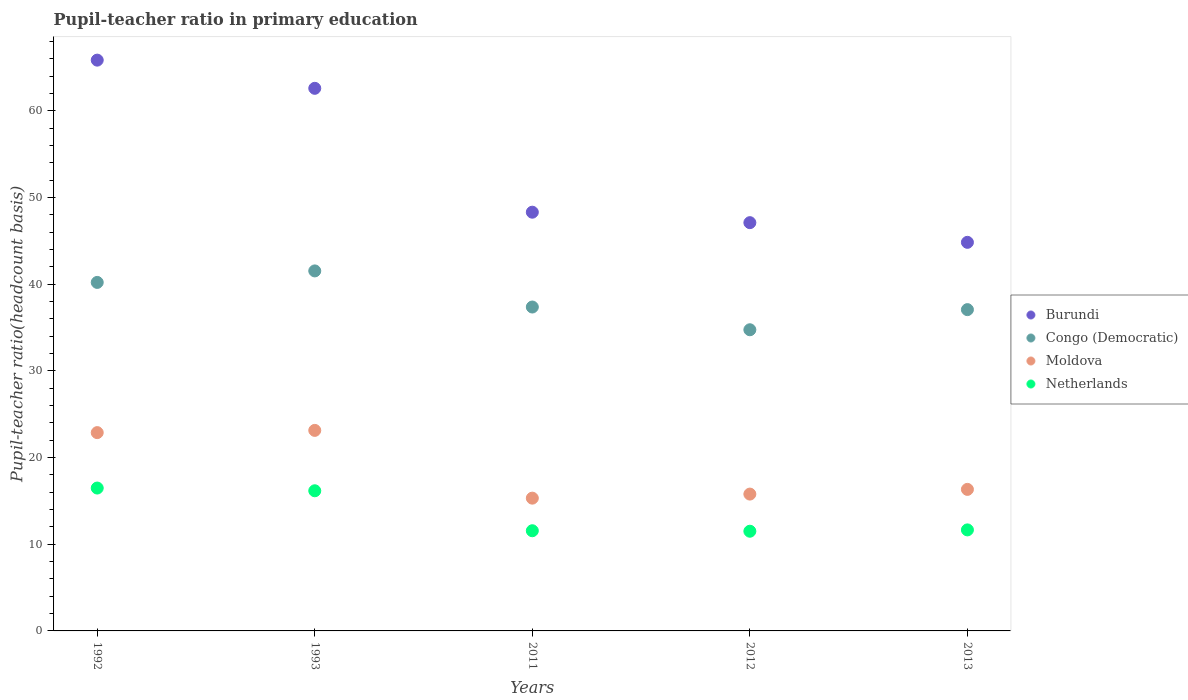How many different coloured dotlines are there?
Ensure brevity in your answer.  4. Is the number of dotlines equal to the number of legend labels?
Provide a short and direct response. Yes. What is the pupil-teacher ratio in primary education in Moldova in 2012?
Make the answer very short. 15.79. Across all years, what is the maximum pupil-teacher ratio in primary education in Netherlands?
Give a very brief answer. 16.48. Across all years, what is the minimum pupil-teacher ratio in primary education in Moldova?
Make the answer very short. 15.32. In which year was the pupil-teacher ratio in primary education in Burundi minimum?
Offer a terse response. 2013. What is the total pupil-teacher ratio in primary education in Burundi in the graph?
Your answer should be compact. 268.71. What is the difference between the pupil-teacher ratio in primary education in Congo (Democratic) in 1992 and that in 2013?
Offer a terse response. 3.14. What is the difference between the pupil-teacher ratio in primary education in Burundi in 1993 and the pupil-teacher ratio in primary education in Netherlands in 2012?
Your response must be concise. 51.1. What is the average pupil-teacher ratio in primary education in Netherlands per year?
Make the answer very short. 13.47. In the year 2011, what is the difference between the pupil-teacher ratio in primary education in Netherlands and pupil-teacher ratio in primary education in Congo (Democratic)?
Provide a short and direct response. -25.81. In how many years, is the pupil-teacher ratio in primary education in Burundi greater than 54?
Provide a short and direct response. 2. What is the ratio of the pupil-teacher ratio in primary education in Congo (Democratic) in 1992 to that in 1993?
Your answer should be very brief. 0.97. Is the pupil-teacher ratio in primary education in Netherlands in 1993 less than that in 2013?
Provide a short and direct response. No. What is the difference between the highest and the second highest pupil-teacher ratio in primary education in Moldova?
Your response must be concise. 0.26. What is the difference between the highest and the lowest pupil-teacher ratio in primary education in Burundi?
Give a very brief answer. 21.02. In how many years, is the pupil-teacher ratio in primary education in Burundi greater than the average pupil-teacher ratio in primary education in Burundi taken over all years?
Your answer should be very brief. 2. Is the sum of the pupil-teacher ratio in primary education in Moldova in 1993 and 2011 greater than the maximum pupil-teacher ratio in primary education in Congo (Democratic) across all years?
Provide a succinct answer. No. Is it the case that in every year, the sum of the pupil-teacher ratio in primary education in Burundi and pupil-teacher ratio in primary education in Moldova  is greater than the pupil-teacher ratio in primary education in Netherlands?
Provide a succinct answer. Yes. Does the pupil-teacher ratio in primary education in Burundi monotonically increase over the years?
Offer a terse response. No. Is the pupil-teacher ratio in primary education in Congo (Democratic) strictly greater than the pupil-teacher ratio in primary education in Netherlands over the years?
Give a very brief answer. Yes. How many dotlines are there?
Ensure brevity in your answer.  4. Where does the legend appear in the graph?
Make the answer very short. Center right. How are the legend labels stacked?
Provide a short and direct response. Vertical. What is the title of the graph?
Your answer should be compact. Pupil-teacher ratio in primary education. Does "Egypt, Arab Rep." appear as one of the legend labels in the graph?
Give a very brief answer. No. What is the label or title of the Y-axis?
Give a very brief answer. Pupil-teacher ratio(headcount basis). What is the Pupil-teacher ratio(headcount basis) in Burundi in 1992?
Offer a very short reply. 65.86. What is the Pupil-teacher ratio(headcount basis) of Congo (Democratic) in 1992?
Keep it short and to the point. 40.21. What is the Pupil-teacher ratio(headcount basis) of Moldova in 1992?
Your response must be concise. 22.88. What is the Pupil-teacher ratio(headcount basis) in Netherlands in 1992?
Offer a very short reply. 16.48. What is the Pupil-teacher ratio(headcount basis) in Burundi in 1993?
Your answer should be compact. 62.6. What is the Pupil-teacher ratio(headcount basis) in Congo (Democratic) in 1993?
Give a very brief answer. 41.54. What is the Pupil-teacher ratio(headcount basis) in Moldova in 1993?
Give a very brief answer. 23.14. What is the Pupil-teacher ratio(headcount basis) of Netherlands in 1993?
Your answer should be compact. 16.17. What is the Pupil-teacher ratio(headcount basis) of Burundi in 2011?
Your answer should be very brief. 48.31. What is the Pupil-teacher ratio(headcount basis) in Congo (Democratic) in 2011?
Offer a terse response. 37.37. What is the Pupil-teacher ratio(headcount basis) of Moldova in 2011?
Offer a terse response. 15.32. What is the Pupil-teacher ratio(headcount basis) of Netherlands in 2011?
Your answer should be very brief. 11.56. What is the Pupil-teacher ratio(headcount basis) in Burundi in 2012?
Provide a short and direct response. 47.1. What is the Pupil-teacher ratio(headcount basis) of Congo (Democratic) in 2012?
Offer a very short reply. 34.75. What is the Pupil-teacher ratio(headcount basis) in Moldova in 2012?
Provide a succinct answer. 15.79. What is the Pupil-teacher ratio(headcount basis) of Netherlands in 2012?
Keep it short and to the point. 11.5. What is the Pupil-teacher ratio(headcount basis) in Burundi in 2013?
Your answer should be very brief. 44.83. What is the Pupil-teacher ratio(headcount basis) in Congo (Democratic) in 2013?
Give a very brief answer. 37.07. What is the Pupil-teacher ratio(headcount basis) in Moldova in 2013?
Make the answer very short. 16.33. What is the Pupil-teacher ratio(headcount basis) in Netherlands in 2013?
Offer a terse response. 11.66. Across all years, what is the maximum Pupil-teacher ratio(headcount basis) in Burundi?
Offer a terse response. 65.86. Across all years, what is the maximum Pupil-teacher ratio(headcount basis) in Congo (Democratic)?
Your answer should be very brief. 41.54. Across all years, what is the maximum Pupil-teacher ratio(headcount basis) of Moldova?
Ensure brevity in your answer.  23.14. Across all years, what is the maximum Pupil-teacher ratio(headcount basis) of Netherlands?
Provide a succinct answer. 16.48. Across all years, what is the minimum Pupil-teacher ratio(headcount basis) of Burundi?
Make the answer very short. 44.83. Across all years, what is the minimum Pupil-teacher ratio(headcount basis) of Congo (Democratic)?
Your answer should be very brief. 34.75. Across all years, what is the minimum Pupil-teacher ratio(headcount basis) in Moldova?
Offer a very short reply. 15.32. Across all years, what is the minimum Pupil-teacher ratio(headcount basis) of Netherlands?
Provide a succinct answer. 11.5. What is the total Pupil-teacher ratio(headcount basis) of Burundi in the graph?
Give a very brief answer. 268.71. What is the total Pupil-teacher ratio(headcount basis) in Congo (Democratic) in the graph?
Provide a short and direct response. 190.93. What is the total Pupil-teacher ratio(headcount basis) in Moldova in the graph?
Provide a succinct answer. 93.45. What is the total Pupil-teacher ratio(headcount basis) of Netherlands in the graph?
Your answer should be compact. 67.37. What is the difference between the Pupil-teacher ratio(headcount basis) of Burundi in 1992 and that in 1993?
Provide a short and direct response. 3.25. What is the difference between the Pupil-teacher ratio(headcount basis) in Congo (Democratic) in 1992 and that in 1993?
Ensure brevity in your answer.  -1.33. What is the difference between the Pupil-teacher ratio(headcount basis) in Moldova in 1992 and that in 1993?
Your answer should be compact. -0.26. What is the difference between the Pupil-teacher ratio(headcount basis) in Netherlands in 1992 and that in 1993?
Your answer should be compact. 0.31. What is the difference between the Pupil-teacher ratio(headcount basis) of Burundi in 1992 and that in 2011?
Your answer should be very brief. 17.55. What is the difference between the Pupil-teacher ratio(headcount basis) in Congo (Democratic) in 1992 and that in 2011?
Make the answer very short. 2.84. What is the difference between the Pupil-teacher ratio(headcount basis) in Moldova in 1992 and that in 2011?
Ensure brevity in your answer.  7.56. What is the difference between the Pupil-teacher ratio(headcount basis) in Netherlands in 1992 and that in 2011?
Your answer should be compact. 4.93. What is the difference between the Pupil-teacher ratio(headcount basis) of Burundi in 1992 and that in 2012?
Your response must be concise. 18.75. What is the difference between the Pupil-teacher ratio(headcount basis) of Congo (Democratic) in 1992 and that in 2012?
Your answer should be very brief. 5.46. What is the difference between the Pupil-teacher ratio(headcount basis) in Moldova in 1992 and that in 2012?
Your answer should be compact. 7.09. What is the difference between the Pupil-teacher ratio(headcount basis) in Netherlands in 1992 and that in 2012?
Give a very brief answer. 4.98. What is the difference between the Pupil-teacher ratio(headcount basis) in Burundi in 1992 and that in 2013?
Make the answer very short. 21.02. What is the difference between the Pupil-teacher ratio(headcount basis) in Congo (Democratic) in 1992 and that in 2013?
Ensure brevity in your answer.  3.14. What is the difference between the Pupil-teacher ratio(headcount basis) in Moldova in 1992 and that in 2013?
Offer a terse response. 6.55. What is the difference between the Pupil-teacher ratio(headcount basis) of Netherlands in 1992 and that in 2013?
Your answer should be very brief. 4.83. What is the difference between the Pupil-teacher ratio(headcount basis) in Burundi in 1993 and that in 2011?
Your response must be concise. 14.29. What is the difference between the Pupil-teacher ratio(headcount basis) of Congo (Democratic) in 1993 and that in 2011?
Give a very brief answer. 4.17. What is the difference between the Pupil-teacher ratio(headcount basis) in Moldova in 1993 and that in 2011?
Offer a very short reply. 7.82. What is the difference between the Pupil-teacher ratio(headcount basis) in Netherlands in 1993 and that in 2011?
Provide a succinct answer. 4.61. What is the difference between the Pupil-teacher ratio(headcount basis) of Burundi in 1993 and that in 2012?
Give a very brief answer. 15.5. What is the difference between the Pupil-teacher ratio(headcount basis) in Congo (Democratic) in 1993 and that in 2012?
Keep it short and to the point. 6.79. What is the difference between the Pupil-teacher ratio(headcount basis) of Moldova in 1993 and that in 2012?
Make the answer very short. 7.35. What is the difference between the Pupil-teacher ratio(headcount basis) of Netherlands in 1993 and that in 2012?
Your response must be concise. 4.67. What is the difference between the Pupil-teacher ratio(headcount basis) of Burundi in 1993 and that in 2013?
Your response must be concise. 17.77. What is the difference between the Pupil-teacher ratio(headcount basis) of Congo (Democratic) in 1993 and that in 2013?
Keep it short and to the point. 4.47. What is the difference between the Pupil-teacher ratio(headcount basis) of Moldova in 1993 and that in 2013?
Your response must be concise. 6.81. What is the difference between the Pupil-teacher ratio(headcount basis) in Netherlands in 1993 and that in 2013?
Provide a succinct answer. 4.51. What is the difference between the Pupil-teacher ratio(headcount basis) of Burundi in 2011 and that in 2012?
Give a very brief answer. 1.21. What is the difference between the Pupil-teacher ratio(headcount basis) of Congo (Democratic) in 2011 and that in 2012?
Your answer should be compact. 2.62. What is the difference between the Pupil-teacher ratio(headcount basis) of Moldova in 2011 and that in 2012?
Your answer should be compact. -0.47. What is the difference between the Pupil-teacher ratio(headcount basis) in Netherlands in 2011 and that in 2012?
Provide a short and direct response. 0.06. What is the difference between the Pupil-teacher ratio(headcount basis) of Burundi in 2011 and that in 2013?
Ensure brevity in your answer.  3.48. What is the difference between the Pupil-teacher ratio(headcount basis) in Congo (Democratic) in 2011 and that in 2013?
Provide a succinct answer. 0.3. What is the difference between the Pupil-teacher ratio(headcount basis) of Moldova in 2011 and that in 2013?
Your response must be concise. -1.01. What is the difference between the Pupil-teacher ratio(headcount basis) in Netherlands in 2011 and that in 2013?
Provide a short and direct response. -0.1. What is the difference between the Pupil-teacher ratio(headcount basis) of Burundi in 2012 and that in 2013?
Keep it short and to the point. 2.27. What is the difference between the Pupil-teacher ratio(headcount basis) of Congo (Democratic) in 2012 and that in 2013?
Provide a succinct answer. -2.32. What is the difference between the Pupil-teacher ratio(headcount basis) in Moldova in 2012 and that in 2013?
Keep it short and to the point. -0.54. What is the difference between the Pupil-teacher ratio(headcount basis) in Netherlands in 2012 and that in 2013?
Provide a succinct answer. -0.15. What is the difference between the Pupil-teacher ratio(headcount basis) in Burundi in 1992 and the Pupil-teacher ratio(headcount basis) in Congo (Democratic) in 1993?
Make the answer very short. 24.32. What is the difference between the Pupil-teacher ratio(headcount basis) of Burundi in 1992 and the Pupil-teacher ratio(headcount basis) of Moldova in 1993?
Keep it short and to the point. 42.72. What is the difference between the Pupil-teacher ratio(headcount basis) of Burundi in 1992 and the Pupil-teacher ratio(headcount basis) of Netherlands in 1993?
Provide a succinct answer. 49.69. What is the difference between the Pupil-teacher ratio(headcount basis) of Congo (Democratic) in 1992 and the Pupil-teacher ratio(headcount basis) of Moldova in 1993?
Make the answer very short. 17.07. What is the difference between the Pupil-teacher ratio(headcount basis) of Congo (Democratic) in 1992 and the Pupil-teacher ratio(headcount basis) of Netherlands in 1993?
Make the answer very short. 24.04. What is the difference between the Pupil-teacher ratio(headcount basis) in Moldova in 1992 and the Pupil-teacher ratio(headcount basis) in Netherlands in 1993?
Provide a short and direct response. 6.71. What is the difference between the Pupil-teacher ratio(headcount basis) of Burundi in 1992 and the Pupil-teacher ratio(headcount basis) of Congo (Democratic) in 2011?
Offer a terse response. 28.49. What is the difference between the Pupil-teacher ratio(headcount basis) in Burundi in 1992 and the Pupil-teacher ratio(headcount basis) in Moldova in 2011?
Make the answer very short. 50.54. What is the difference between the Pupil-teacher ratio(headcount basis) in Burundi in 1992 and the Pupil-teacher ratio(headcount basis) in Netherlands in 2011?
Provide a succinct answer. 54.3. What is the difference between the Pupil-teacher ratio(headcount basis) of Congo (Democratic) in 1992 and the Pupil-teacher ratio(headcount basis) of Moldova in 2011?
Ensure brevity in your answer.  24.89. What is the difference between the Pupil-teacher ratio(headcount basis) of Congo (Democratic) in 1992 and the Pupil-teacher ratio(headcount basis) of Netherlands in 2011?
Provide a short and direct response. 28.65. What is the difference between the Pupil-teacher ratio(headcount basis) in Moldova in 1992 and the Pupil-teacher ratio(headcount basis) in Netherlands in 2011?
Give a very brief answer. 11.32. What is the difference between the Pupil-teacher ratio(headcount basis) in Burundi in 1992 and the Pupil-teacher ratio(headcount basis) in Congo (Democratic) in 2012?
Your answer should be very brief. 31.11. What is the difference between the Pupil-teacher ratio(headcount basis) in Burundi in 1992 and the Pupil-teacher ratio(headcount basis) in Moldova in 2012?
Your answer should be very brief. 50.07. What is the difference between the Pupil-teacher ratio(headcount basis) of Burundi in 1992 and the Pupil-teacher ratio(headcount basis) of Netherlands in 2012?
Your response must be concise. 54.35. What is the difference between the Pupil-teacher ratio(headcount basis) in Congo (Democratic) in 1992 and the Pupil-teacher ratio(headcount basis) in Moldova in 2012?
Provide a short and direct response. 24.42. What is the difference between the Pupil-teacher ratio(headcount basis) in Congo (Democratic) in 1992 and the Pupil-teacher ratio(headcount basis) in Netherlands in 2012?
Your answer should be compact. 28.71. What is the difference between the Pupil-teacher ratio(headcount basis) of Moldova in 1992 and the Pupil-teacher ratio(headcount basis) of Netherlands in 2012?
Make the answer very short. 11.38. What is the difference between the Pupil-teacher ratio(headcount basis) of Burundi in 1992 and the Pupil-teacher ratio(headcount basis) of Congo (Democratic) in 2013?
Offer a terse response. 28.79. What is the difference between the Pupil-teacher ratio(headcount basis) in Burundi in 1992 and the Pupil-teacher ratio(headcount basis) in Moldova in 2013?
Provide a succinct answer. 49.53. What is the difference between the Pupil-teacher ratio(headcount basis) in Burundi in 1992 and the Pupil-teacher ratio(headcount basis) in Netherlands in 2013?
Make the answer very short. 54.2. What is the difference between the Pupil-teacher ratio(headcount basis) in Congo (Democratic) in 1992 and the Pupil-teacher ratio(headcount basis) in Moldova in 2013?
Your response must be concise. 23.88. What is the difference between the Pupil-teacher ratio(headcount basis) in Congo (Democratic) in 1992 and the Pupil-teacher ratio(headcount basis) in Netherlands in 2013?
Make the answer very short. 28.55. What is the difference between the Pupil-teacher ratio(headcount basis) in Moldova in 1992 and the Pupil-teacher ratio(headcount basis) in Netherlands in 2013?
Your answer should be very brief. 11.22. What is the difference between the Pupil-teacher ratio(headcount basis) in Burundi in 1993 and the Pupil-teacher ratio(headcount basis) in Congo (Democratic) in 2011?
Offer a terse response. 25.23. What is the difference between the Pupil-teacher ratio(headcount basis) in Burundi in 1993 and the Pupil-teacher ratio(headcount basis) in Moldova in 2011?
Your response must be concise. 47.29. What is the difference between the Pupil-teacher ratio(headcount basis) in Burundi in 1993 and the Pupil-teacher ratio(headcount basis) in Netherlands in 2011?
Offer a very short reply. 51.05. What is the difference between the Pupil-teacher ratio(headcount basis) in Congo (Democratic) in 1993 and the Pupil-teacher ratio(headcount basis) in Moldova in 2011?
Provide a short and direct response. 26.22. What is the difference between the Pupil-teacher ratio(headcount basis) of Congo (Democratic) in 1993 and the Pupil-teacher ratio(headcount basis) of Netherlands in 2011?
Your response must be concise. 29.98. What is the difference between the Pupil-teacher ratio(headcount basis) in Moldova in 1993 and the Pupil-teacher ratio(headcount basis) in Netherlands in 2011?
Make the answer very short. 11.58. What is the difference between the Pupil-teacher ratio(headcount basis) of Burundi in 1993 and the Pupil-teacher ratio(headcount basis) of Congo (Democratic) in 2012?
Provide a succinct answer. 27.86. What is the difference between the Pupil-teacher ratio(headcount basis) in Burundi in 1993 and the Pupil-teacher ratio(headcount basis) in Moldova in 2012?
Offer a very short reply. 46.82. What is the difference between the Pupil-teacher ratio(headcount basis) in Burundi in 1993 and the Pupil-teacher ratio(headcount basis) in Netherlands in 2012?
Your response must be concise. 51.1. What is the difference between the Pupil-teacher ratio(headcount basis) of Congo (Democratic) in 1993 and the Pupil-teacher ratio(headcount basis) of Moldova in 2012?
Give a very brief answer. 25.75. What is the difference between the Pupil-teacher ratio(headcount basis) in Congo (Democratic) in 1993 and the Pupil-teacher ratio(headcount basis) in Netherlands in 2012?
Make the answer very short. 30.03. What is the difference between the Pupil-teacher ratio(headcount basis) in Moldova in 1993 and the Pupil-teacher ratio(headcount basis) in Netherlands in 2012?
Provide a succinct answer. 11.63. What is the difference between the Pupil-teacher ratio(headcount basis) in Burundi in 1993 and the Pupil-teacher ratio(headcount basis) in Congo (Democratic) in 2013?
Your answer should be compact. 25.54. What is the difference between the Pupil-teacher ratio(headcount basis) in Burundi in 1993 and the Pupil-teacher ratio(headcount basis) in Moldova in 2013?
Your response must be concise. 46.27. What is the difference between the Pupil-teacher ratio(headcount basis) of Burundi in 1993 and the Pupil-teacher ratio(headcount basis) of Netherlands in 2013?
Make the answer very short. 50.95. What is the difference between the Pupil-teacher ratio(headcount basis) in Congo (Democratic) in 1993 and the Pupil-teacher ratio(headcount basis) in Moldova in 2013?
Offer a terse response. 25.21. What is the difference between the Pupil-teacher ratio(headcount basis) of Congo (Democratic) in 1993 and the Pupil-teacher ratio(headcount basis) of Netherlands in 2013?
Make the answer very short. 29.88. What is the difference between the Pupil-teacher ratio(headcount basis) in Moldova in 1993 and the Pupil-teacher ratio(headcount basis) in Netherlands in 2013?
Provide a succinct answer. 11.48. What is the difference between the Pupil-teacher ratio(headcount basis) in Burundi in 2011 and the Pupil-teacher ratio(headcount basis) in Congo (Democratic) in 2012?
Your answer should be compact. 13.56. What is the difference between the Pupil-teacher ratio(headcount basis) of Burundi in 2011 and the Pupil-teacher ratio(headcount basis) of Moldova in 2012?
Your response must be concise. 32.52. What is the difference between the Pupil-teacher ratio(headcount basis) of Burundi in 2011 and the Pupil-teacher ratio(headcount basis) of Netherlands in 2012?
Your answer should be compact. 36.81. What is the difference between the Pupil-teacher ratio(headcount basis) in Congo (Democratic) in 2011 and the Pupil-teacher ratio(headcount basis) in Moldova in 2012?
Ensure brevity in your answer.  21.58. What is the difference between the Pupil-teacher ratio(headcount basis) of Congo (Democratic) in 2011 and the Pupil-teacher ratio(headcount basis) of Netherlands in 2012?
Ensure brevity in your answer.  25.87. What is the difference between the Pupil-teacher ratio(headcount basis) in Moldova in 2011 and the Pupil-teacher ratio(headcount basis) in Netherlands in 2012?
Provide a short and direct response. 3.82. What is the difference between the Pupil-teacher ratio(headcount basis) of Burundi in 2011 and the Pupil-teacher ratio(headcount basis) of Congo (Democratic) in 2013?
Make the answer very short. 11.24. What is the difference between the Pupil-teacher ratio(headcount basis) of Burundi in 2011 and the Pupil-teacher ratio(headcount basis) of Moldova in 2013?
Keep it short and to the point. 31.98. What is the difference between the Pupil-teacher ratio(headcount basis) in Burundi in 2011 and the Pupil-teacher ratio(headcount basis) in Netherlands in 2013?
Offer a very short reply. 36.66. What is the difference between the Pupil-teacher ratio(headcount basis) of Congo (Democratic) in 2011 and the Pupil-teacher ratio(headcount basis) of Moldova in 2013?
Ensure brevity in your answer.  21.04. What is the difference between the Pupil-teacher ratio(headcount basis) in Congo (Democratic) in 2011 and the Pupil-teacher ratio(headcount basis) in Netherlands in 2013?
Offer a terse response. 25.71. What is the difference between the Pupil-teacher ratio(headcount basis) in Moldova in 2011 and the Pupil-teacher ratio(headcount basis) in Netherlands in 2013?
Keep it short and to the point. 3.66. What is the difference between the Pupil-teacher ratio(headcount basis) in Burundi in 2012 and the Pupil-teacher ratio(headcount basis) in Congo (Democratic) in 2013?
Your answer should be very brief. 10.04. What is the difference between the Pupil-teacher ratio(headcount basis) of Burundi in 2012 and the Pupil-teacher ratio(headcount basis) of Moldova in 2013?
Offer a terse response. 30.77. What is the difference between the Pupil-teacher ratio(headcount basis) of Burundi in 2012 and the Pupil-teacher ratio(headcount basis) of Netherlands in 2013?
Ensure brevity in your answer.  35.45. What is the difference between the Pupil-teacher ratio(headcount basis) in Congo (Democratic) in 2012 and the Pupil-teacher ratio(headcount basis) in Moldova in 2013?
Keep it short and to the point. 18.42. What is the difference between the Pupil-teacher ratio(headcount basis) in Congo (Democratic) in 2012 and the Pupil-teacher ratio(headcount basis) in Netherlands in 2013?
Offer a terse response. 23.09. What is the difference between the Pupil-teacher ratio(headcount basis) in Moldova in 2012 and the Pupil-teacher ratio(headcount basis) in Netherlands in 2013?
Ensure brevity in your answer.  4.13. What is the average Pupil-teacher ratio(headcount basis) in Burundi per year?
Offer a very short reply. 53.74. What is the average Pupil-teacher ratio(headcount basis) of Congo (Democratic) per year?
Your answer should be compact. 38.19. What is the average Pupil-teacher ratio(headcount basis) of Moldova per year?
Offer a very short reply. 18.69. What is the average Pupil-teacher ratio(headcount basis) of Netherlands per year?
Provide a short and direct response. 13.47. In the year 1992, what is the difference between the Pupil-teacher ratio(headcount basis) of Burundi and Pupil-teacher ratio(headcount basis) of Congo (Democratic)?
Provide a succinct answer. 25.65. In the year 1992, what is the difference between the Pupil-teacher ratio(headcount basis) of Burundi and Pupil-teacher ratio(headcount basis) of Moldova?
Make the answer very short. 42.98. In the year 1992, what is the difference between the Pupil-teacher ratio(headcount basis) in Burundi and Pupil-teacher ratio(headcount basis) in Netherlands?
Ensure brevity in your answer.  49.37. In the year 1992, what is the difference between the Pupil-teacher ratio(headcount basis) in Congo (Democratic) and Pupil-teacher ratio(headcount basis) in Moldova?
Ensure brevity in your answer.  17.33. In the year 1992, what is the difference between the Pupil-teacher ratio(headcount basis) in Congo (Democratic) and Pupil-teacher ratio(headcount basis) in Netherlands?
Provide a short and direct response. 23.73. In the year 1992, what is the difference between the Pupil-teacher ratio(headcount basis) of Moldova and Pupil-teacher ratio(headcount basis) of Netherlands?
Give a very brief answer. 6.4. In the year 1993, what is the difference between the Pupil-teacher ratio(headcount basis) of Burundi and Pupil-teacher ratio(headcount basis) of Congo (Democratic)?
Your answer should be very brief. 21.07. In the year 1993, what is the difference between the Pupil-teacher ratio(headcount basis) in Burundi and Pupil-teacher ratio(headcount basis) in Moldova?
Make the answer very short. 39.47. In the year 1993, what is the difference between the Pupil-teacher ratio(headcount basis) of Burundi and Pupil-teacher ratio(headcount basis) of Netherlands?
Offer a terse response. 46.43. In the year 1993, what is the difference between the Pupil-teacher ratio(headcount basis) of Congo (Democratic) and Pupil-teacher ratio(headcount basis) of Moldova?
Your answer should be very brief. 18.4. In the year 1993, what is the difference between the Pupil-teacher ratio(headcount basis) in Congo (Democratic) and Pupil-teacher ratio(headcount basis) in Netherlands?
Provide a succinct answer. 25.37. In the year 1993, what is the difference between the Pupil-teacher ratio(headcount basis) in Moldova and Pupil-teacher ratio(headcount basis) in Netherlands?
Your answer should be very brief. 6.97. In the year 2011, what is the difference between the Pupil-teacher ratio(headcount basis) in Burundi and Pupil-teacher ratio(headcount basis) in Congo (Democratic)?
Make the answer very short. 10.94. In the year 2011, what is the difference between the Pupil-teacher ratio(headcount basis) of Burundi and Pupil-teacher ratio(headcount basis) of Moldova?
Your response must be concise. 32.99. In the year 2011, what is the difference between the Pupil-teacher ratio(headcount basis) in Burundi and Pupil-teacher ratio(headcount basis) in Netherlands?
Give a very brief answer. 36.75. In the year 2011, what is the difference between the Pupil-teacher ratio(headcount basis) of Congo (Democratic) and Pupil-teacher ratio(headcount basis) of Moldova?
Your answer should be compact. 22.05. In the year 2011, what is the difference between the Pupil-teacher ratio(headcount basis) of Congo (Democratic) and Pupil-teacher ratio(headcount basis) of Netherlands?
Provide a succinct answer. 25.81. In the year 2011, what is the difference between the Pupil-teacher ratio(headcount basis) in Moldova and Pupil-teacher ratio(headcount basis) in Netherlands?
Your answer should be very brief. 3.76. In the year 2012, what is the difference between the Pupil-teacher ratio(headcount basis) of Burundi and Pupil-teacher ratio(headcount basis) of Congo (Democratic)?
Provide a succinct answer. 12.36. In the year 2012, what is the difference between the Pupil-teacher ratio(headcount basis) of Burundi and Pupil-teacher ratio(headcount basis) of Moldova?
Provide a succinct answer. 31.32. In the year 2012, what is the difference between the Pupil-teacher ratio(headcount basis) in Burundi and Pupil-teacher ratio(headcount basis) in Netherlands?
Give a very brief answer. 35.6. In the year 2012, what is the difference between the Pupil-teacher ratio(headcount basis) in Congo (Democratic) and Pupil-teacher ratio(headcount basis) in Moldova?
Offer a terse response. 18.96. In the year 2012, what is the difference between the Pupil-teacher ratio(headcount basis) in Congo (Democratic) and Pupil-teacher ratio(headcount basis) in Netherlands?
Your response must be concise. 23.25. In the year 2012, what is the difference between the Pupil-teacher ratio(headcount basis) in Moldova and Pupil-teacher ratio(headcount basis) in Netherlands?
Make the answer very short. 4.29. In the year 2013, what is the difference between the Pupil-teacher ratio(headcount basis) of Burundi and Pupil-teacher ratio(headcount basis) of Congo (Democratic)?
Make the answer very short. 7.76. In the year 2013, what is the difference between the Pupil-teacher ratio(headcount basis) in Burundi and Pupil-teacher ratio(headcount basis) in Moldova?
Ensure brevity in your answer.  28.5. In the year 2013, what is the difference between the Pupil-teacher ratio(headcount basis) of Burundi and Pupil-teacher ratio(headcount basis) of Netherlands?
Offer a terse response. 33.18. In the year 2013, what is the difference between the Pupil-teacher ratio(headcount basis) in Congo (Democratic) and Pupil-teacher ratio(headcount basis) in Moldova?
Ensure brevity in your answer.  20.74. In the year 2013, what is the difference between the Pupil-teacher ratio(headcount basis) in Congo (Democratic) and Pupil-teacher ratio(headcount basis) in Netherlands?
Make the answer very short. 25.41. In the year 2013, what is the difference between the Pupil-teacher ratio(headcount basis) of Moldova and Pupil-teacher ratio(headcount basis) of Netherlands?
Provide a short and direct response. 4.67. What is the ratio of the Pupil-teacher ratio(headcount basis) of Burundi in 1992 to that in 1993?
Give a very brief answer. 1.05. What is the ratio of the Pupil-teacher ratio(headcount basis) in Congo (Democratic) in 1992 to that in 1993?
Provide a short and direct response. 0.97. What is the ratio of the Pupil-teacher ratio(headcount basis) in Moldova in 1992 to that in 1993?
Your answer should be very brief. 0.99. What is the ratio of the Pupil-teacher ratio(headcount basis) of Netherlands in 1992 to that in 1993?
Give a very brief answer. 1.02. What is the ratio of the Pupil-teacher ratio(headcount basis) in Burundi in 1992 to that in 2011?
Your answer should be compact. 1.36. What is the ratio of the Pupil-teacher ratio(headcount basis) of Congo (Democratic) in 1992 to that in 2011?
Your response must be concise. 1.08. What is the ratio of the Pupil-teacher ratio(headcount basis) of Moldova in 1992 to that in 2011?
Make the answer very short. 1.49. What is the ratio of the Pupil-teacher ratio(headcount basis) of Netherlands in 1992 to that in 2011?
Offer a very short reply. 1.43. What is the ratio of the Pupil-teacher ratio(headcount basis) in Burundi in 1992 to that in 2012?
Ensure brevity in your answer.  1.4. What is the ratio of the Pupil-teacher ratio(headcount basis) of Congo (Democratic) in 1992 to that in 2012?
Ensure brevity in your answer.  1.16. What is the ratio of the Pupil-teacher ratio(headcount basis) of Moldova in 1992 to that in 2012?
Provide a succinct answer. 1.45. What is the ratio of the Pupil-teacher ratio(headcount basis) of Netherlands in 1992 to that in 2012?
Offer a terse response. 1.43. What is the ratio of the Pupil-teacher ratio(headcount basis) of Burundi in 1992 to that in 2013?
Provide a succinct answer. 1.47. What is the ratio of the Pupil-teacher ratio(headcount basis) in Congo (Democratic) in 1992 to that in 2013?
Your answer should be compact. 1.08. What is the ratio of the Pupil-teacher ratio(headcount basis) in Moldova in 1992 to that in 2013?
Your answer should be very brief. 1.4. What is the ratio of the Pupil-teacher ratio(headcount basis) of Netherlands in 1992 to that in 2013?
Make the answer very short. 1.41. What is the ratio of the Pupil-teacher ratio(headcount basis) of Burundi in 1993 to that in 2011?
Offer a terse response. 1.3. What is the ratio of the Pupil-teacher ratio(headcount basis) of Congo (Democratic) in 1993 to that in 2011?
Ensure brevity in your answer.  1.11. What is the ratio of the Pupil-teacher ratio(headcount basis) in Moldova in 1993 to that in 2011?
Your response must be concise. 1.51. What is the ratio of the Pupil-teacher ratio(headcount basis) of Netherlands in 1993 to that in 2011?
Provide a succinct answer. 1.4. What is the ratio of the Pupil-teacher ratio(headcount basis) in Burundi in 1993 to that in 2012?
Your answer should be very brief. 1.33. What is the ratio of the Pupil-teacher ratio(headcount basis) in Congo (Democratic) in 1993 to that in 2012?
Your answer should be very brief. 1.2. What is the ratio of the Pupil-teacher ratio(headcount basis) of Moldova in 1993 to that in 2012?
Offer a terse response. 1.47. What is the ratio of the Pupil-teacher ratio(headcount basis) of Netherlands in 1993 to that in 2012?
Keep it short and to the point. 1.41. What is the ratio of the Pupil-teacher ratio(headcount basis) in Burundi in 1993 to that in 2013?
Keep it short and to the point. 1.4. What is the ratio of the Pupil-teacher ratio(headcount basis) in Congo (Democratic) in 1993 to that in 2013?
Your answer should be very brief. 1.12. What is the ratio of the Pupil-teacher ratio(headcount basis) in Moldova in 1993 to that in 2013?
Make the answer very short. 1.42. What is the ratio of the Pupil-teacher ratio(headcount basis) of Netherlands in 1993 to that in 2013?
Keep it short and to the point. 1.39. What is the ratio of the Pupil-teacher ratio(headcount basis) of Burundi in 2011 to that in 2012?
Your answer should be very brief. 1.03. What is the ratio of the Pupil-teacher ratio(headcount basis) in Congo (Democratic) in 2011 to that in 2012?
Offer a terse response. 1.08. What is the ratio of the Pupil-teacher ratio(headcount basis) in Moldova in 2011 to that in 2012?
Keep it short and to the point. 0.97. What is the ratio of the Pupil-teacher ratio(headcount basis) in Burundi in 2011 to that in 2013?
Your answer should be compact. 1.08. What is the ratio of the Pupil-teacher ratio(headcount basis) of Congo (Democratic) in 2011 to that in 2013?
Keep it short and to the point. 1.01. What is the ratio of the Pupil-teacher ratio(headcount basis) in Moldova in 2011 to that in 2013?
Give a very brief answer. 0.94. What is the ratio of the Pupil-teacher ratio(headcount basis) of Netherlands in 2011 to that in 2013?
Ensure brevity in your answer.  0.99. What is the ratio of the Pupil-teacher ratio(headcount basis) of Burundi in 2012 to that in 2013?
Offer a terse response. 1.05. What is the ratio of the Pupil-teacher ratio(headcount basis) of Congo (Democratic) in 2012 to that in 2013?
Provide a succinct answer. 0.94. What is the ratio of the Pupil-teacher ratio(headcount basis) in Moldova in 2012 to that in 2013?
Your answer should be very brief. 0.97. What is the difference between the highest and the second highest Pupil-teacher ratio(headcount basis) in Burundi?
Your answer should be very brief. 3.25. What is the difference between the highest and the second highest Pupil-teacher ratio(headcount basis) of Congo (Democratic)?
Offer a very short reply. 1.33. What is the difference between the highest and the second highest Pupil-teacher ratio(headcount basis) of Moldova?
Ensure brevity in your answer.  0.26. What is the difference between the highest and the second highest Pupil-teacher ratio(headcount basis) in Netherlands?
Your answer should be very brief. 0.31. What is the difference between the highest and the lowest Pupil-teacher ratio(headcount basis) of Burundi?
Offer a very short reply. 21.02. What is the difference between the highest and the lowest Pupil-teacher ratio(headcount basis) of Congo (Democratic)?
Your answer should be very brief. 6.79. What is the difference between the highest and the lowest Pupil-teacher ratio(headcount basis) of Moldova?
Provide a short and direct response. 7.82. What is the difference between the highest and the lowest Pupil-teacher ratio(headcount basis) of Netherlands?
Your answer should be compact. 4.98. 